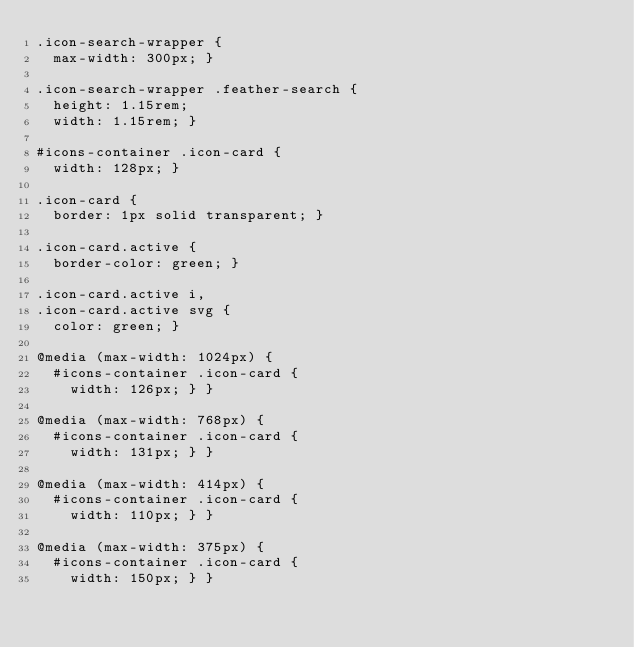<code> <loc_0><loc_0><loc_500><loc_500><_CSS_>.icon-search-wrapper {
  max-width: 300px; }

.icon-search-wrapper .feather-search {
  height: 1.15rem;
  width: 1.15rem; }

#icons-container .icon-card {
  width: 128px; }

.icon-card {
  border: 1px solid transparent; }

.icon-card.active {
  border-color: green; }

.icon-card.active i,
.icon-card.active svg {
  color: green; }

@media (max-width: 1024px) {
  #icons-container .icon-card {
    width: 126px; } }

@media (max-width: 768px) {
  #icons-container .icon-card {
    width: 131px; } }

@media (max-width: 414px) {
  #icons-container .icon-card {
    width: 110px; } }

@media (max-width: 375px) {
  #icons-container .icon-card {
    width: 150px; } }
</code> 